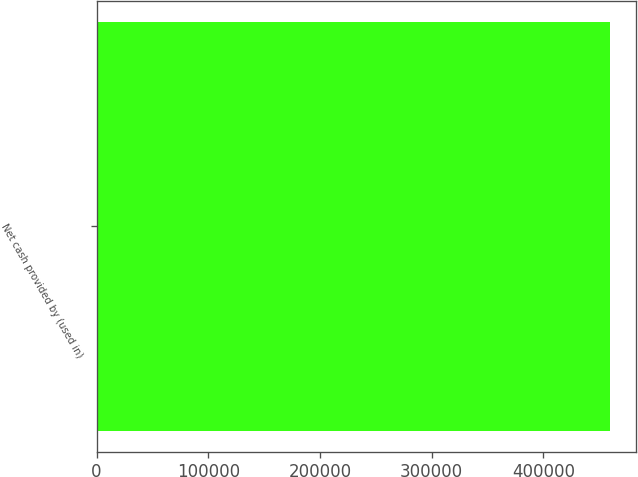Convert chart to OTSL. <chart><loc_0><loc_0><loc_500><loc_500><bar_chart><fcel>Net cash provided by (used in)<nl><fcel>459816<nl></chart> 